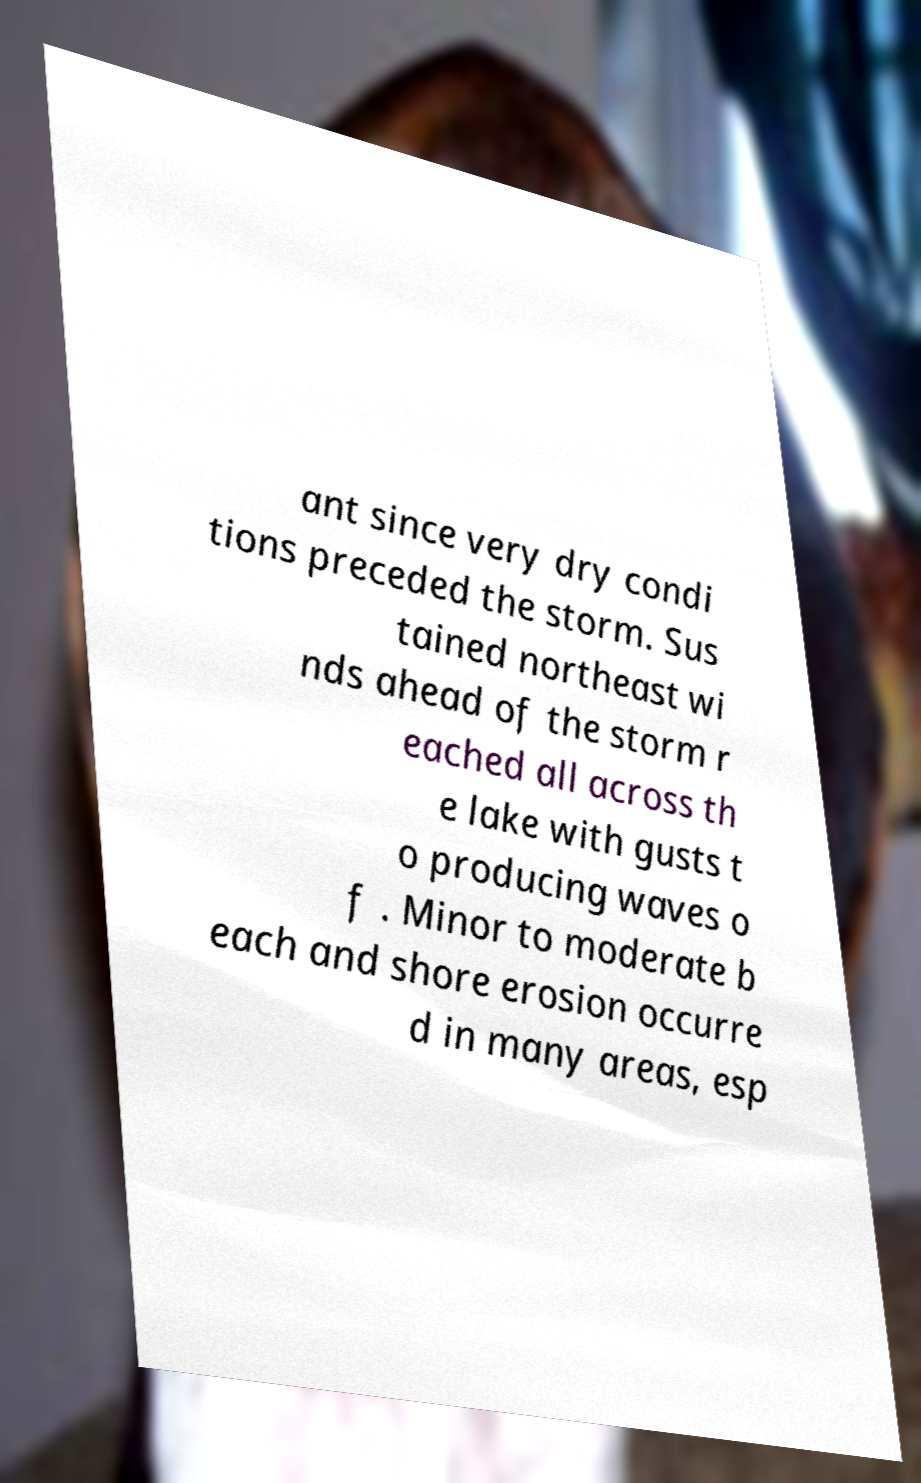Please read and relay the text visible in this image. What does it say? ant since very dry condi tions preceded the storm. Sus tained northeast wi nds ahead of the storm r eached all across th e lake with gusts t o producing waves o f . Minor to moderate b each and shore erosion occurre d in many areas, esp 